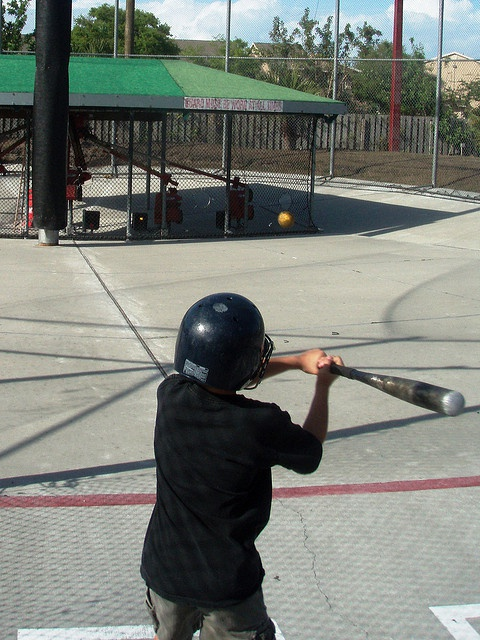Describe the objects in this image and their specific colors. I can see people in teal, black, darkgray, gray, and navy tones, baseball bat in teal, gray, black, and darkgray tones, and sports ball in teal, olive, orange, and black tones in this image. 